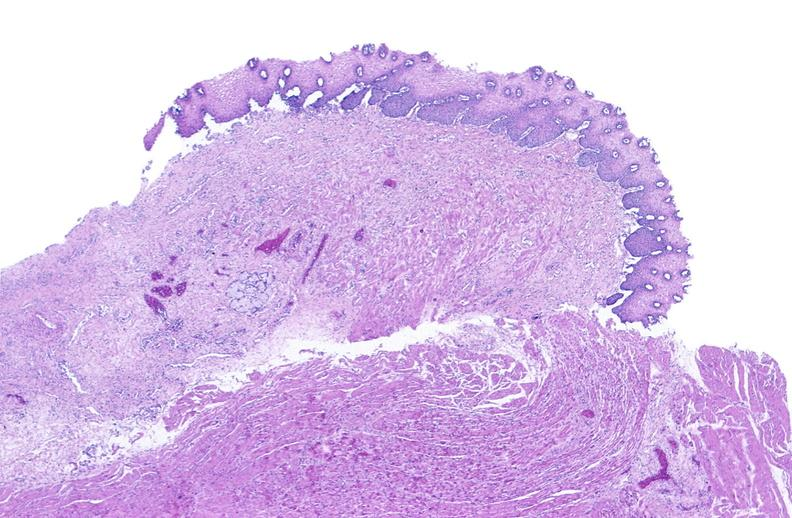what is present?
Answer the question using a single word or phrase. Gastrointestinal 